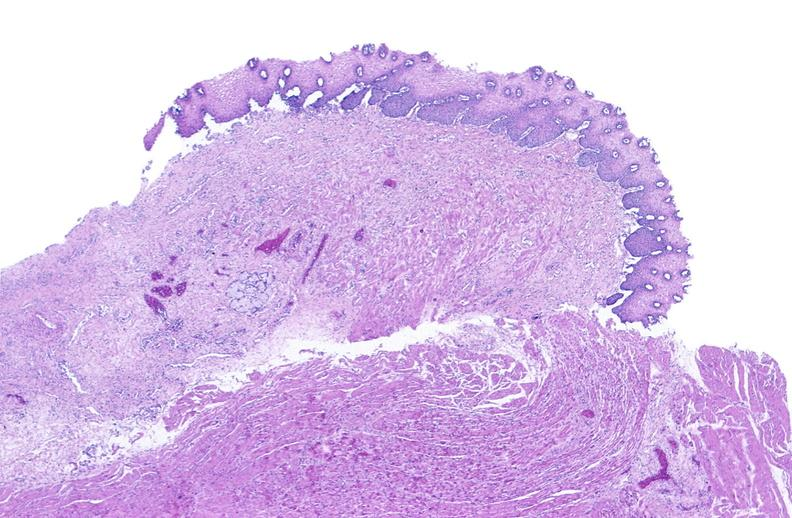what is present?
Answer the question using a single word or phrase. Gastrointestinal 